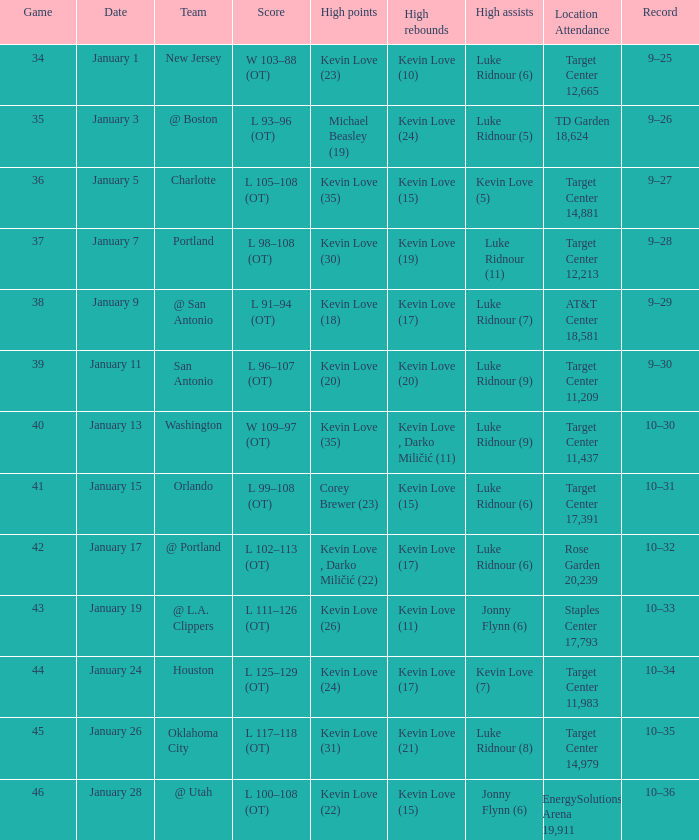When is the event featuring team orlando taking place? January 15. 